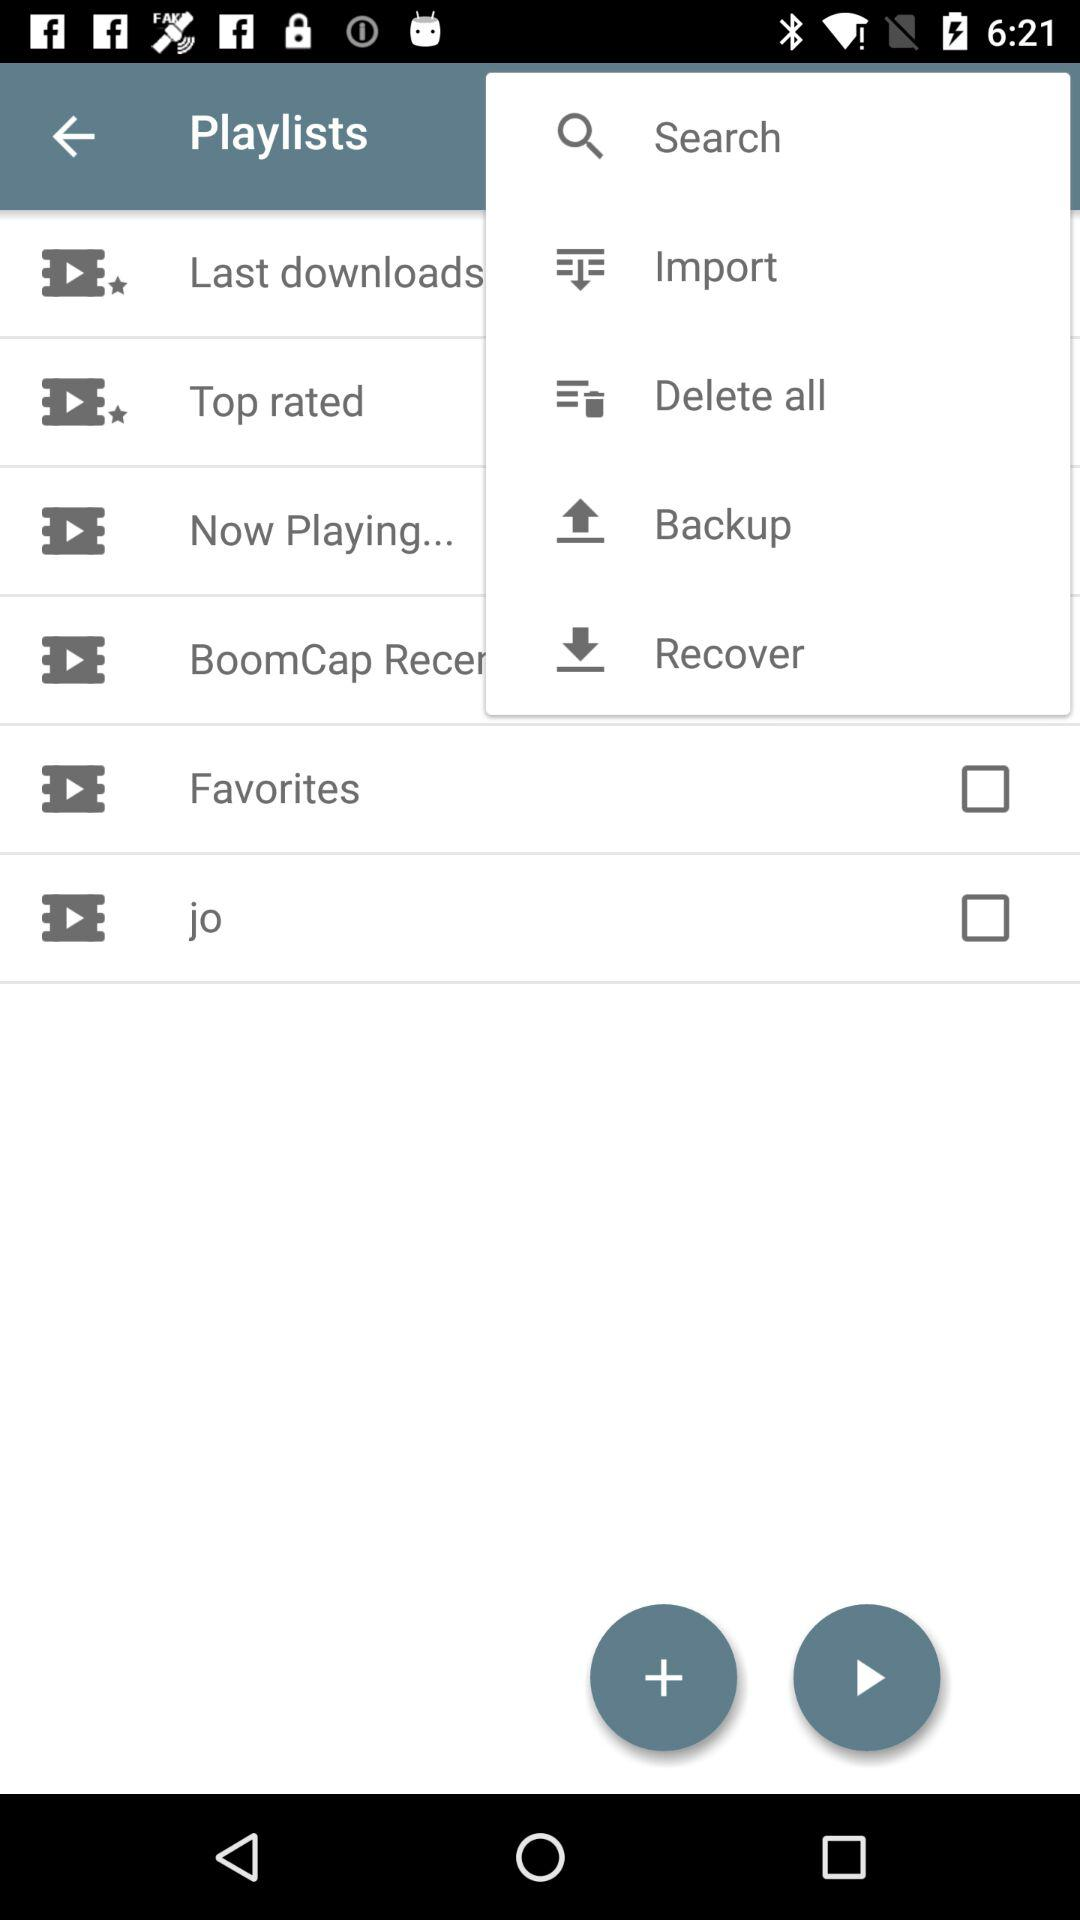What is the status of the "Favorites"? The status of the "Favorites" is "off". 